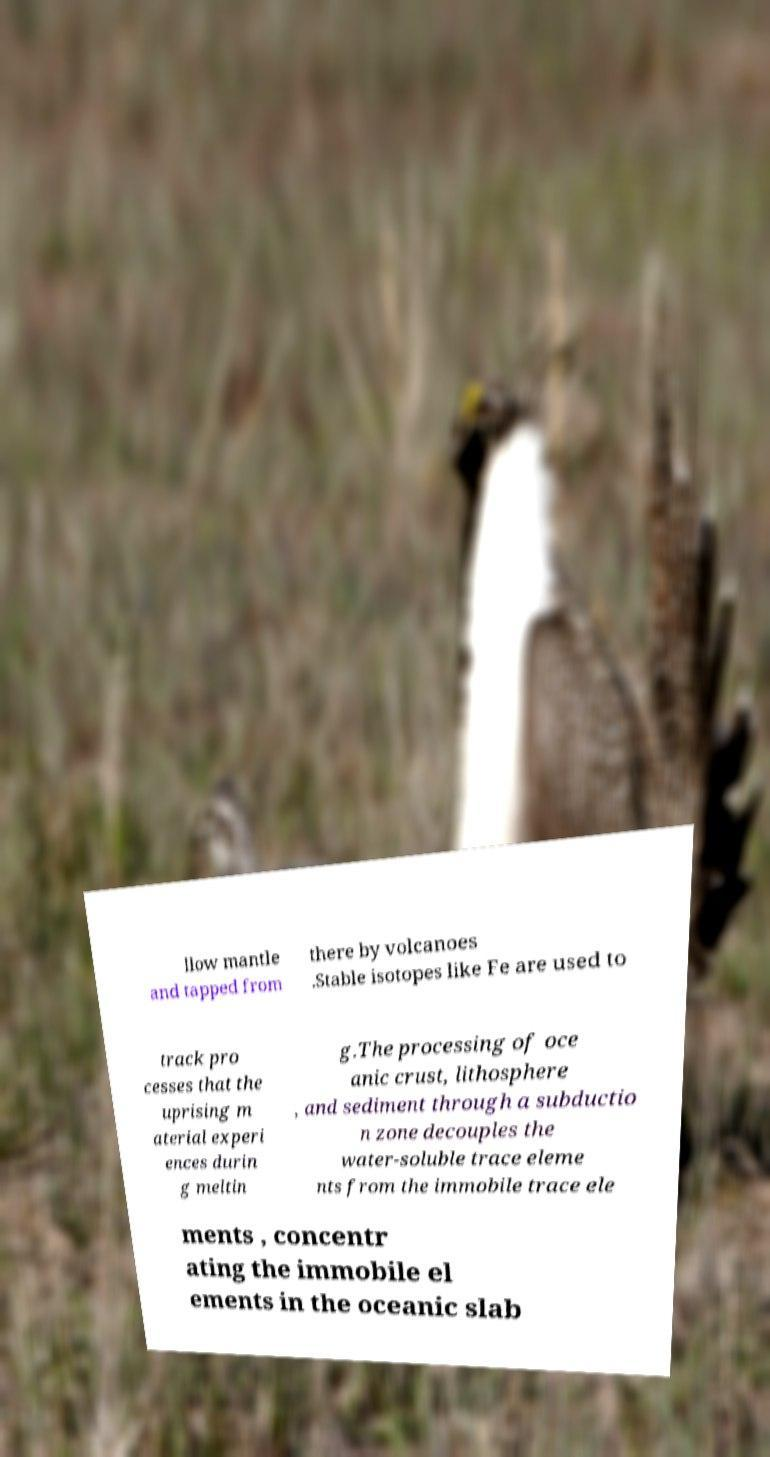There's text embedded in this image that I need extracted. Can you transcribe it verbatim? llow mantle and tapped from there by volcanoes .Stable isotopes like Fe are used to track pro cesses that the uprising m aterial experi ences durin g meltin g.The processing of oce anic crust, lithosphere , and sediment through a subductio n zone decouples the water-soluble trace eleme nts from the immobile trace ele ments , concentr ating the immobile el ements in the oceanic slab 